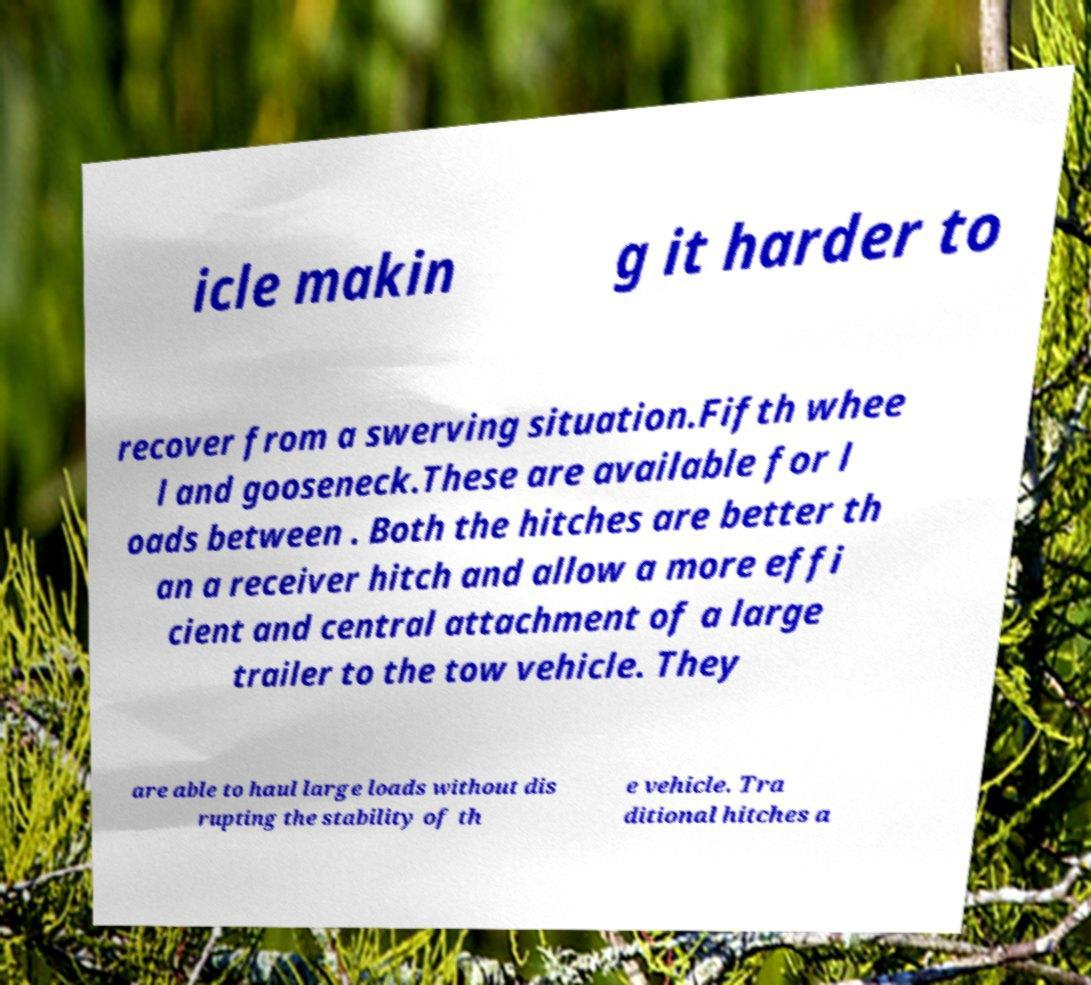There's text embedded in this image that I need extracted. Can you transcribe it verbatim? icle makin g it harder to recover from a swerving situation.Fifth whee l and gooseneck.These are available for l oads between . Both the hitches are better th an a receiver hitch and allow a more effi cient and central attachment of a large trailer to the tow vehicle. They are able to haul large loads without dis rupting the stability of th e vehicle. Tra ditional hitches a 